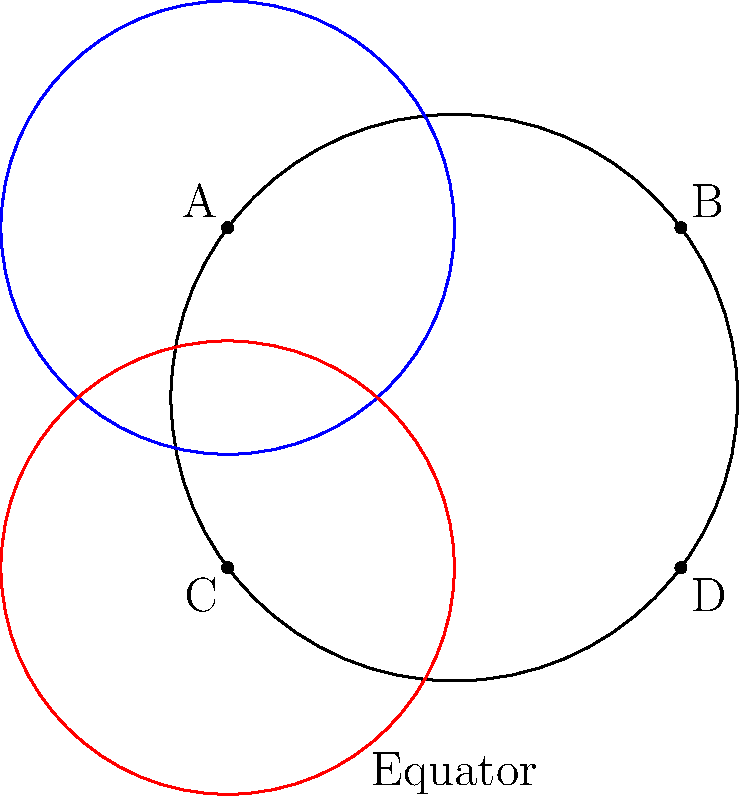In the context of pit stop choreography, consider two parallel lines on a sphere representing the paths of two crew members. If these lines start 90° apart at the equator and extend towards the poles, what is the angle between them at 45° latitude? How might this geometric principle influence the positioning and movement of pit crew members during a stop? To solve this problem, we need to understand the principles of non-Euclidean geometry on a sphere:

1. On a sphere, "parallel" lines (geodesics) that start perpendicular to the equator will converge towards the poles.

2. The angle between these lines at any latitude is given by the formula:

   $$\theta = 90° - \lambda$$

   where $\theta$ is the angle between the lines and $\lambda$ is the latitude.

3. In our case, we're asked about the angle at 45° latitude:

   $$\theta = 90° - 45° = 45°$$

4. This means that the two parallel lines, which started 90° apart at the equator, are now only 45° apart at 45° latitude.

5. In the context of pit stop choreography:
   - This principle demonstrates that crew members moving in seemingly parallel paths may actually be converging as they move around the car.
   - Understanding this convergence is crucial for preventing collisions and optimizing movement patterns.
   - The crew chief can use this knowledge to design more efficient pit stop layouts, ensuring that crew members' paths intersect at the right points for smooth handoffs of tools or tires.
   - It also highlights the importance of timing and spatial awareness, as distances and angles between crew members change as they move around the curved surface of the pit stop area.

6. Practical application:
   - The crew chief might position team members at specific "latitudes" around the car to maintain optimal spacing throughout the pit stop.
   - Movement patterns could be designed to take advantage of this convergence, allowing for more compact and efficient pit stop choreography.
Answer: 45° 